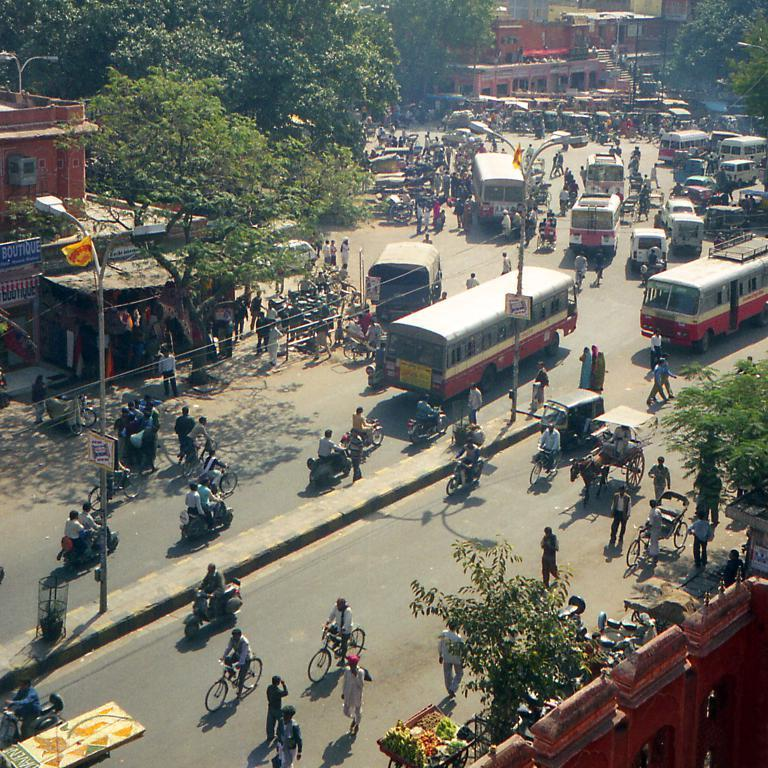What is happening on the road in the image? There are vehicles on the road in the image. Are there any people present in the image? Yes, there are people in the image. What type of infrastructure is present in the image? Street lights and poles are visible in the image. Can you describe any text or signs in the image? There are text or signs on boards in the image. What type of structures can be seen in the image? Buildings are present in the image. What other objects can be seen in the image? Other objects are visible in the image. What type of chalk is being used to draw on the road in the image? There is no chalk present in the image, and no one is drawing on the road. What type of battle is taking place in the image? There is no battle present in the image; it features vehicles on the road, people, street lights, poles, text or signs on boards, buildings, and other objects. 